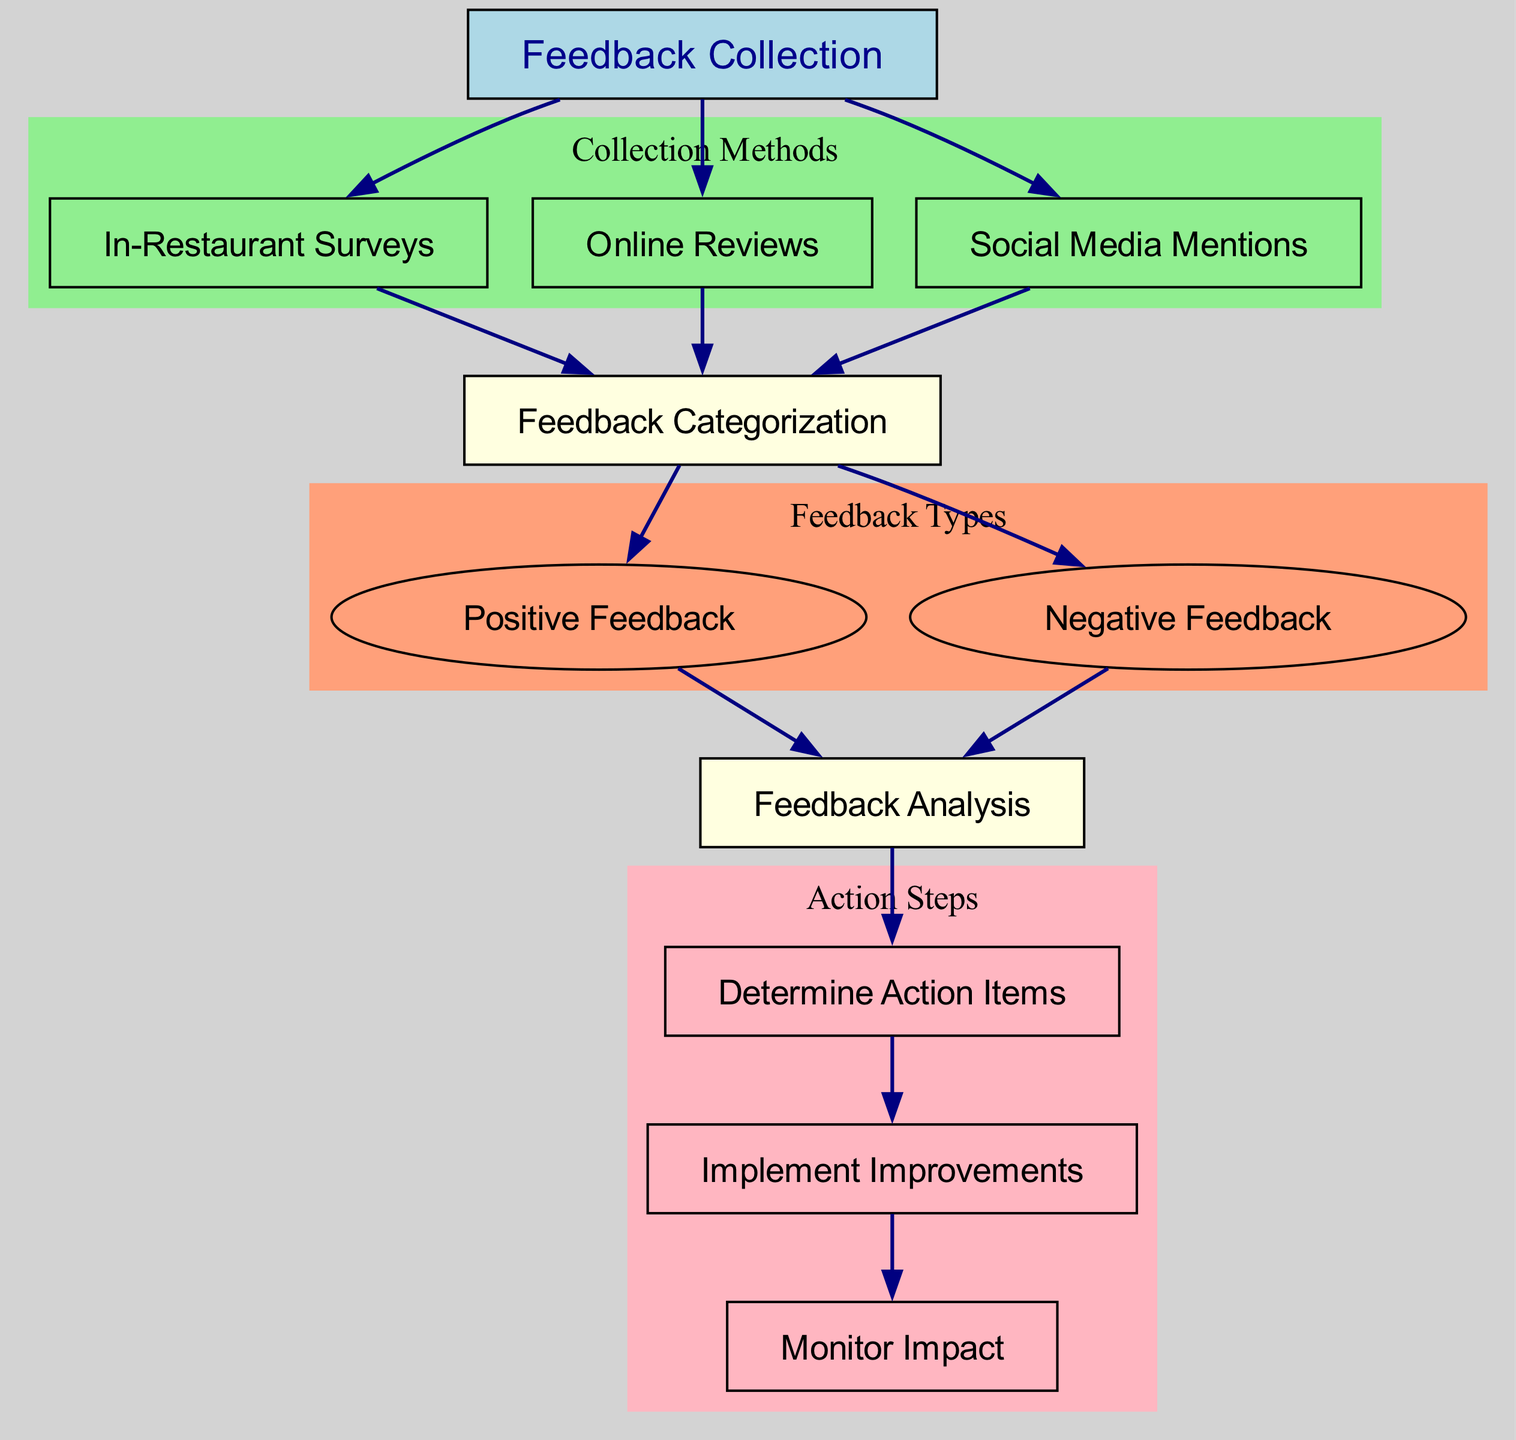What is the first step in the feedback collection process? The first step is represented by the node labeled "Feedback Collection." This node is the starting point of the diagram and indicates where the entire process begins.
Answer: Feedback Collection How many methods are used for collecting feedback? There are three methods indicated by the nodes labeled "In-Restaurant Surveys," "Online Reviews," and "Social Media Mentions." Each method is connected to the "Feedback Collection" node.
Answer: Three What type of feedback does the process categorize? The process categorizes feedback into two types, which are shown in the nodes labeled "Positive Feedback" and "Negative Feedback."
Answer: Two types Which step comes after feedback analysis? The step immediately following "Feedback Analysis" is indicated by the node labeled "Determine Action Items." This can be found as the next direct connection from the analysis step.
Answer: Determine Action Items What is the last action in the feedback process? The last action detailed in the diagram is represented by the node labeled "Monitor Impact." This node illustrates that the process concludes with monitoring the results of any improvements.
Answer: Monitor Impact How are the feedback methods grouped in the diagram? The feedback methods are grouped under a subgraph labeled "Collection Methods." This grouping visually delineates these collection methods from other parts of the feedback process.
Answer: Collection Methods What connection is made directly from negative feedback? The "Negative Feedback" node connects directly to the "Feedback Analysis" node, indicating that negative feedback is analyzed as part of the process.
Answer: Feedback Analysis How do improvements get implemented? Improvements are implemented after identifying action items, as shown by the connection from the "Determine Action Items" node to the "Implement Improvements" node. This step is crucial for progressing the feedback response process.
Answer: Implement Improvements What type of diagram is this? This is a Textbook Diagram, which typically structures information clearly to outline processes. The format helps in visualizing the sequential steps of the customer feedback collection process.
Answer: Textbook Diagram 